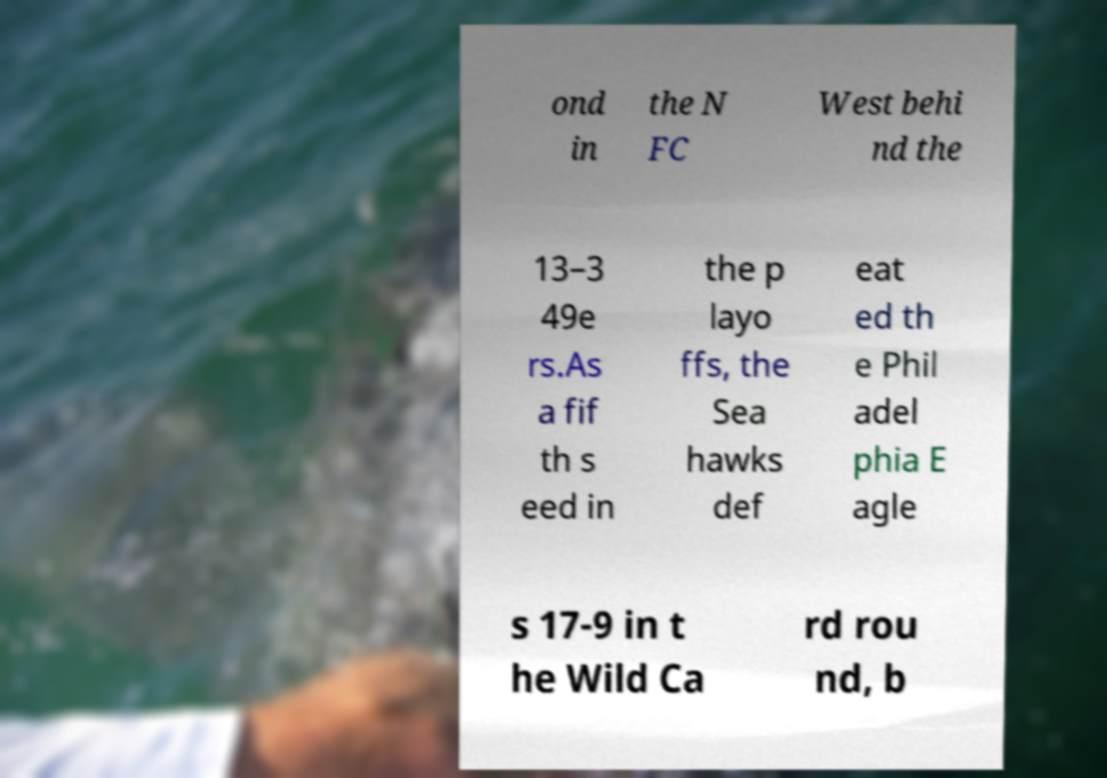Could you assist in decoding the text presented in this image and type it out clearly? ond in the N FC West behi nd the 13–3 49e rs.As a fif th s eed in the p layo ffs, the Sea hawks def eat ed th e Phil adel phia E agle s 17-9 in t he Wild Ca rd rou nd, b 